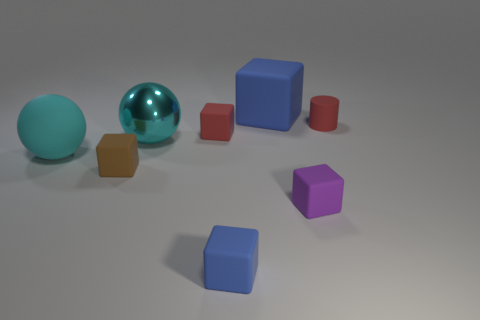Subtract all tiny brown matte cubes. How many cubes are left? 4 Add 2 matte things. How many objects exist? 10 Subtract all cubes. How many objects are left? 3 Subtract 1 blocks. How many blocks are left? 4 Subtract all yellow cubes. Subtract all yellow spheres. How many cubes are left? 5 Subtract all cyan blocks. How many purple cylinders are left? 0 Subtract all large rubber cubes. Subtract all tiny purple rubber objects. How many objects are left? 6 Add 1 small brown matte objects. How many small brown matte objects are left? 2 Add 5 large cylinders. How many large cylinders exist? 5 Subtract all brown blocks. How many blocks are left? 4 